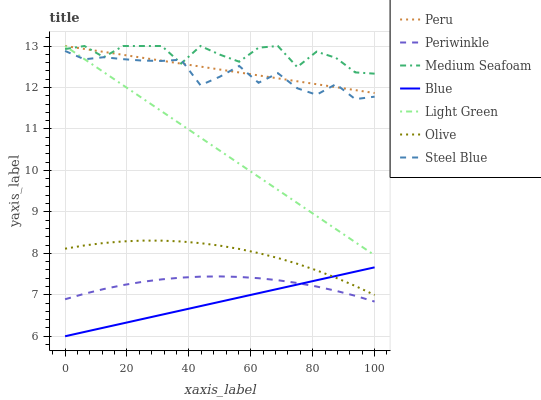Does Blue have the minimum area under the curve?
Answer yes or no. Yes. Does Medium Seafoam have the maximum area under the curve?
Answer yes or no. Yes. Does Peru have the minimum area under the curve?
Answer yes or no. No. Does Peru have the maximum area under the curve?
Answer yes or no. No. Is Blue the smoothest?
Answer yes or no. Yes. Is Medium Seafoam the roughest?
Answer yes or no. Yes. Is Peru the smoothest?
Answer yes or no. No. Is Peru the roughest?
Answer yes or no. No. Does Blue have the lowest value?
Answer yes or no. Yes. Does Peru have the lowest value?
Answer yes or no. No. Does Medium Seafoam have the highest value?
Answer yes or no. Yes. Does Steel Blue have the highest value?
Answer yes or no. No. Is Olive less than Steel Blue?
Answer yes or no. Yes. Is Peru greater than Blue?
Answer yes or no. Yes. Does Light Green intersect Medium Seafoam?
Answer yes or no. Yes. Is Light Green less than Medium Seafoam?
Answer yes or no. No. Is Light Green greater than Medium Seafoam?
Answer yes or no. No. Does Olive intersect Steel Blue?
Answer yes or no. No. 